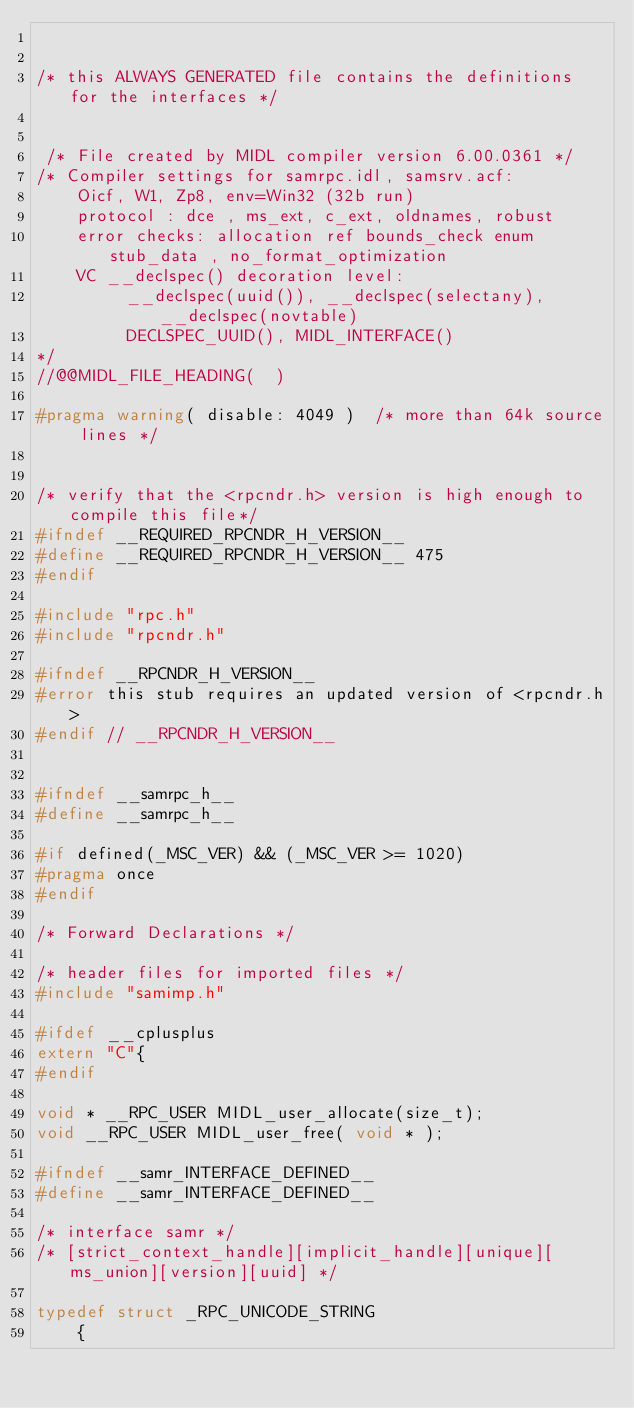<code> <loc_0><loc_0><loc_500><loc_500><_C_>

/* this ALWAYS GENERATED file contains the definitions for the interfaces */


 /* File created by MIDL compiler version 6.00.0361 */
/* Compiler settings for samrpc.idl, samsrv.acf:
    Oicf, W1, Zp8, env=Win32 (32b run)
    protocol : dce , ms_ext, c_ext, oldnames, robust
    error checks: allocation ref bounds_check enum stub_data , no_format_optimization
    VC __declspec() decoration level: 
         __declspec(uuid()), __declspec(selectany), __declspec(novtable)
         DECLSPEC_UUID(), MIDL_INTERFACE()
*/
//@@MIDL_FILE_HEADING(  )

#pragma warning( disable: 4049 )  /* more than 64k source lines */


/* verify that the <rpcndr.h> version is high enough to compile this file*/
#ifndef __REQUIRED_RPCNDR_H_VERSION__
#define __REQUIRED_RPCNDR_H_VERSION__ 475
#endif

#include "rpc.h"
#include "rpcndr.h"

#ifndef __RPCNDR_H_VERSION__
#error this stub requires an updated version of <rpcndr.h>
#endif // __RPCNDR_H_VERSION__


#ifndef __samrpc_h__
#define __samrpc_h__

#if defined(_MSC_VER) && (_MSC_VER >= 1020)
#pragma once
#endif

/* Forward Declarations */ 

/* header files for imported files */
#include "samimp.h"

#ifdef __cplusplus
extern "C"{
#endif 

void * __RPC_USER MIDL_user_allocate(size_t);
void __RPC_USER MIDL_user_free( void * ); 

#ifndef __samr_INTERFACE_DEFINED__
#define __samr_INTERFACE_DEFINED__

/* interface samr */
/* [strict_context_handle][implicit_handle][unique][ms_union][version][uuid] */ 

typedef struct _RPC_UNICODE_STRING
    {</code> 